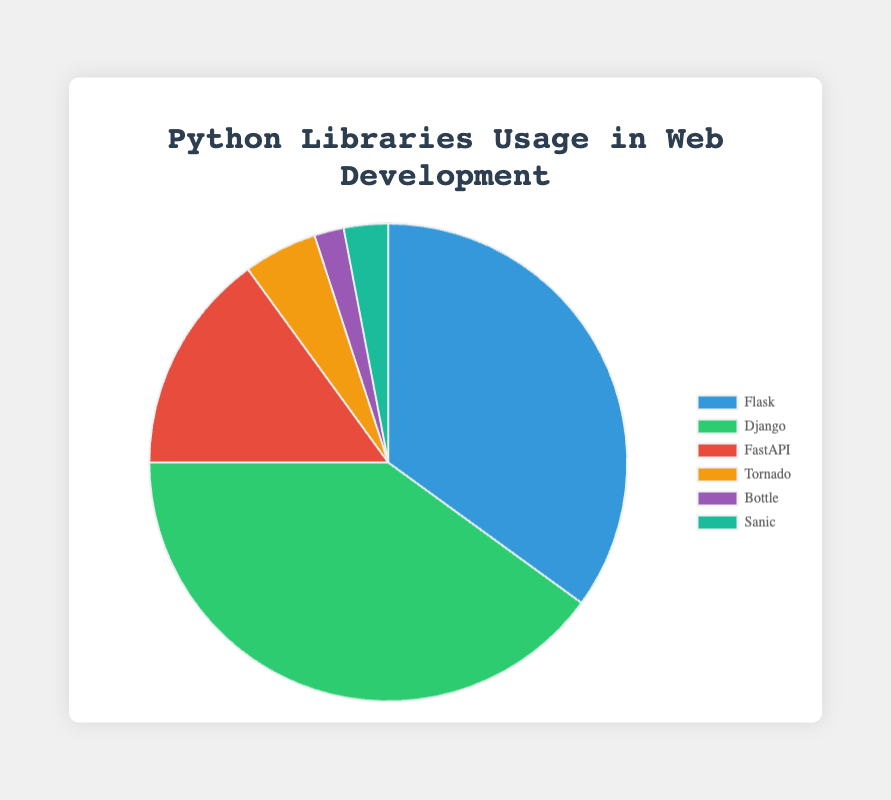Which library is used the most in web development projects? The largest slice of the pie represents the library with the highest usage percentage. In this chart, the largest slice is Django with a usage percentage of 40%.
Answer: Django Which library has a higher usage percentage, Flask or FastAPI? Compare the slices representing Flask and FastAPI. Flask has a usage percentage of 35%, and FastAPI has a usage percentage of 15%.
Answer: Flask What is the total usage percentage of the least used libraries combined (Bottle and Sanic)? Add the usage percentages of Bottle and Sanic. Bottle has a usage percentage of 2%, and Sanic has a usage percentage of 3%, so the total is 2% + 3% = 5%.
Answer: 5% Which usage percentage is greater, Tornado or Bottle? Compare the slices representing Tornado and Bottle. Tornado has a usage percentage of 5%, while Bottle has a usage percentage of 2%.
Answer: Tornado How much more popular is Django compared to FastAPI? Subtract the usage percentage of FastAPI from the usage percentage of Django. Django is 40% and FastAPI is 15%, so 40% - 15% = 25%.
Answer: 25% What is the cumulative usage percentage of Flask, Django, and FastAPI? Add the usage percentages of Flask, Django, and FastAPI. Flask has 35%, Django has 40%, and FastAPI has 15%, so the total is 35% + 40% + 15% = 90%.
Answer: 90% Which libraries have usage percentages less than 10%? Identify the slices with usage percentages less than 10%. Bottle (2%), Sanic (3%), and Tornado (5%) all have usage percentages less than 10%.
Answer: Bottle, Sanic, Tornado What percentage of web development projects use libraries other than Flask and Django? Subtract the combined usage percentage of Flask and Django from 100%. Flask has 35% and Django has 40%, so the total is 35% + 40% = 75%. Therefore, the percentage of projects using other libraries is 100% - 75% = 25%.
Answer: 25% Which library is represented by the slice with a green color? The legend indicates the colors associated with each library. The slice with a green color represents Django.
Answer: Django 